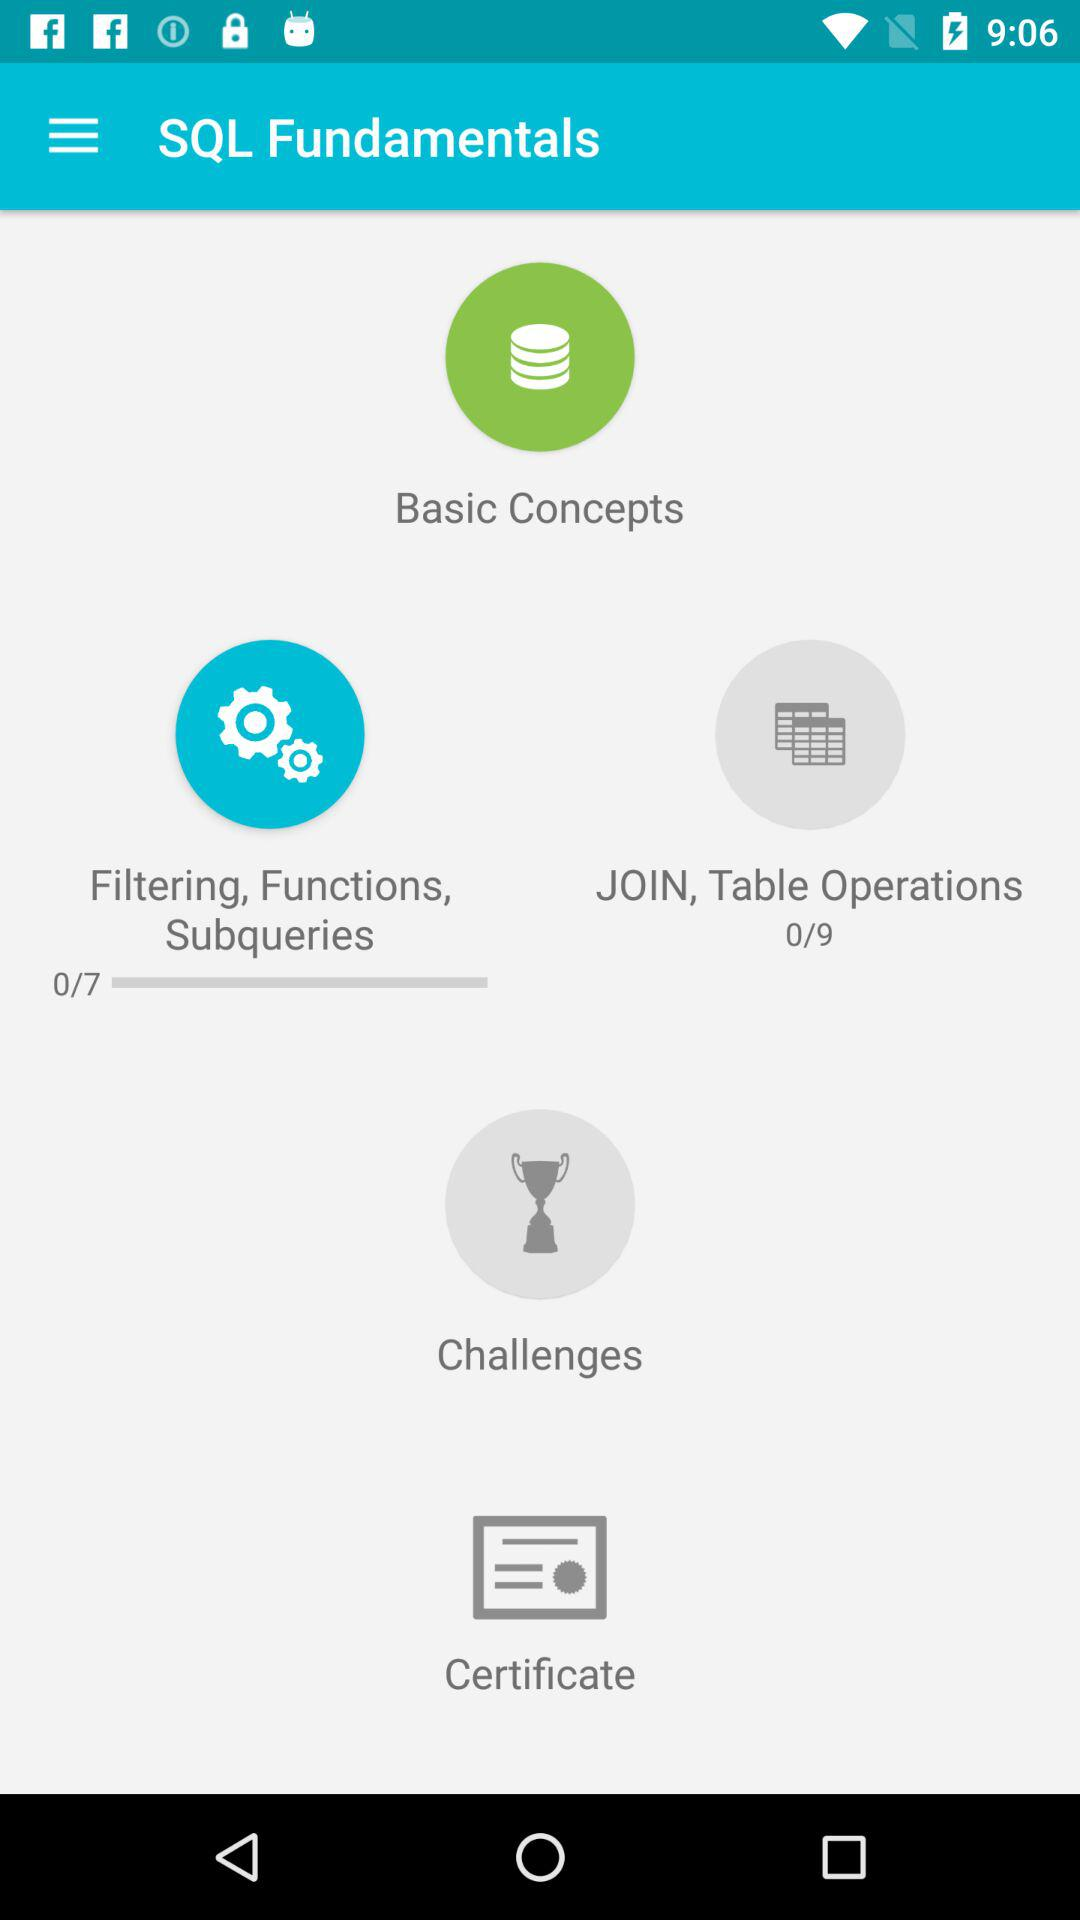How many total tutorials are there for Join, Table operations in SQL fundamentals? There are a total of 9 tutorials. 